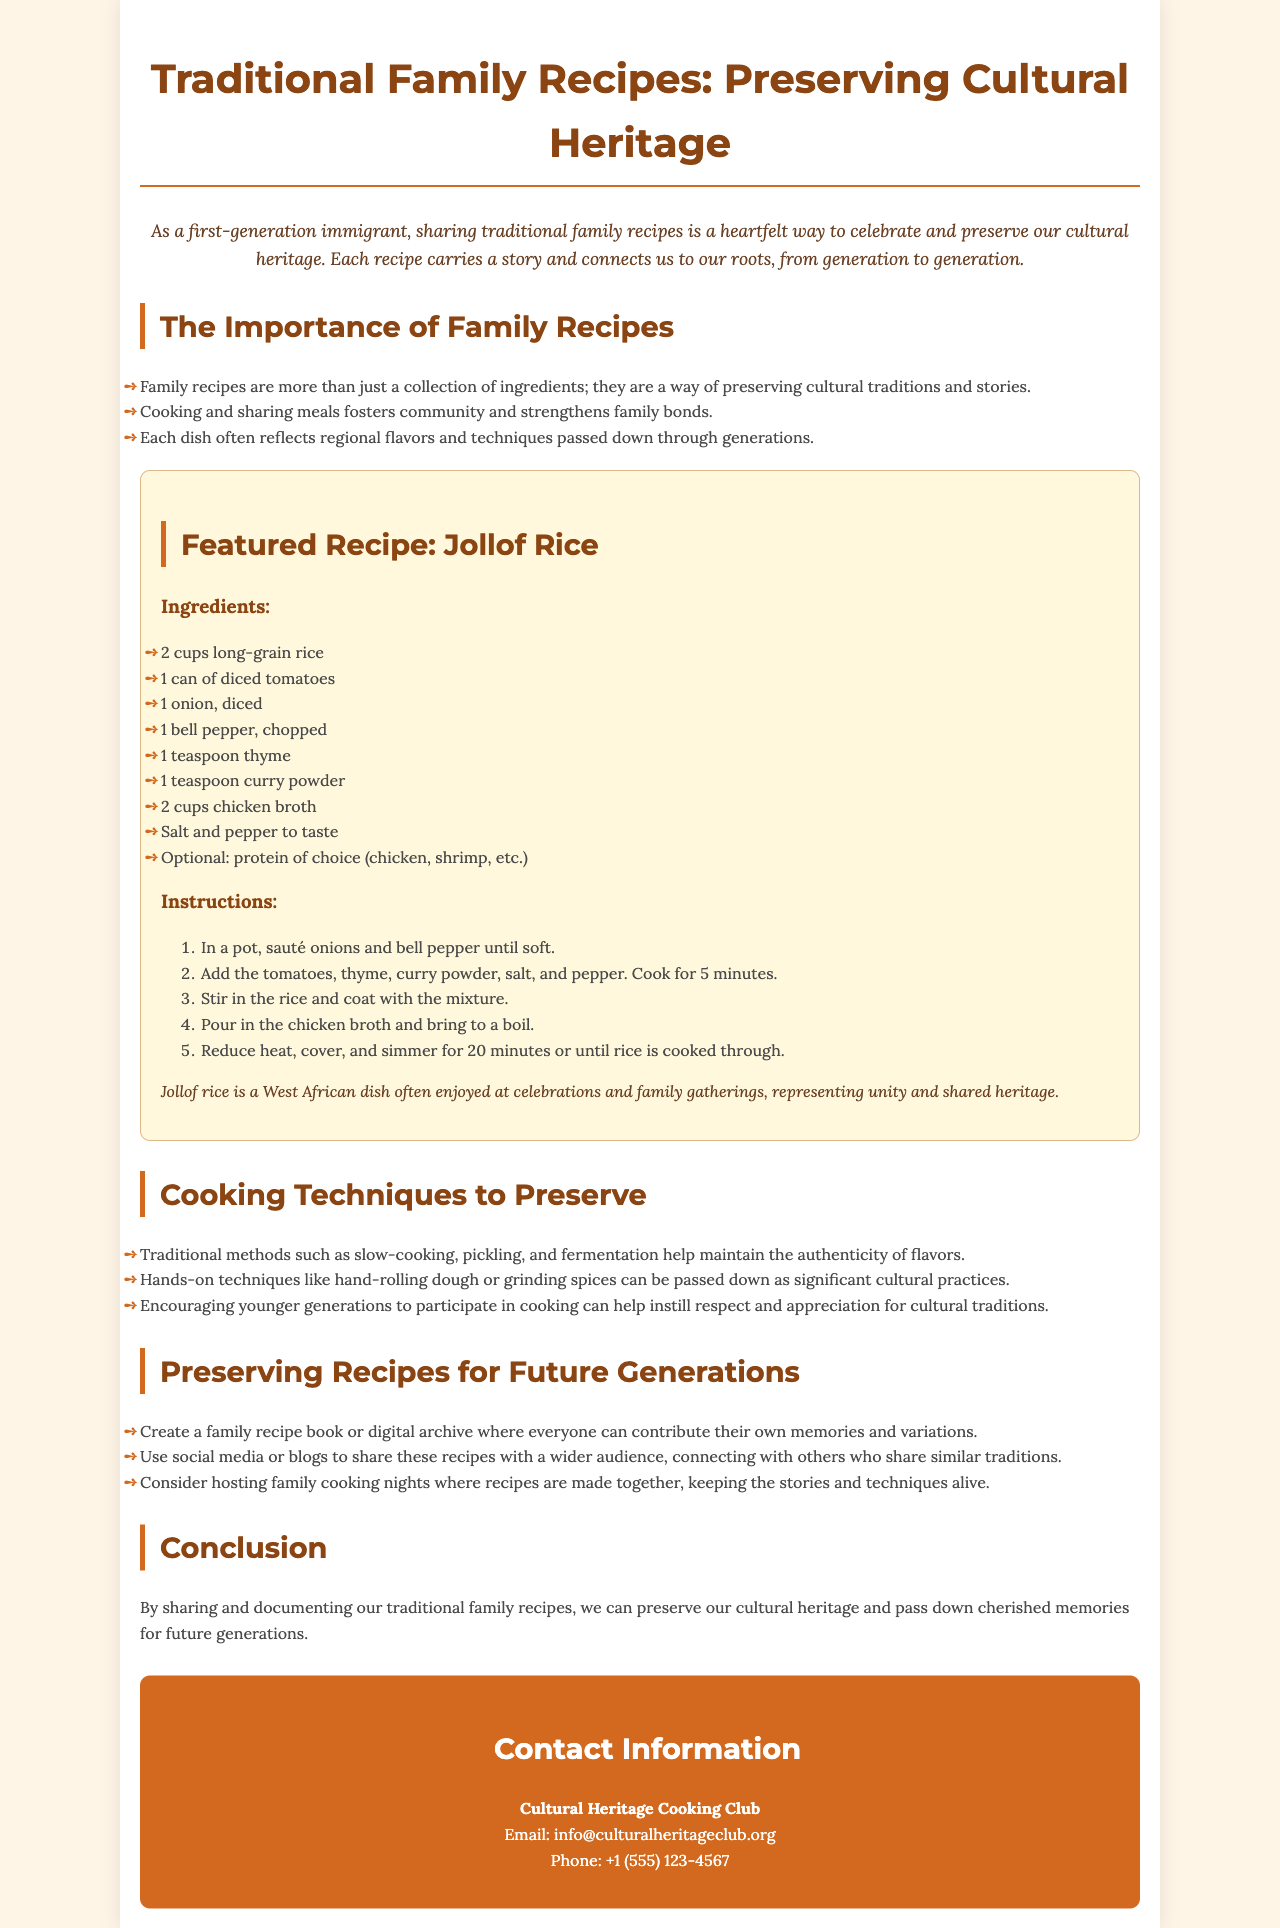What is the title of the brochure? The title of the brochure is prominently displayed at the top and is "Traditional Family Recipes: Preserving Cultural Heritage."
Answer: Traditional Family Recipes: Preserving Cultural Heritage What dish is featured in the document? The featured recipe in the document is specified in the recipe section, which is "Jollof Rice."
Answer: Jollof Rice How many cups of rice are needed for the recipe? The ingredients for Jollof Rice list "2 cups long-grain rice" as a requirement.
Answer: 2 cups What cooking technique is emphasized for preserving authenticity? The document highlights "slow-cooking" as a traditional method to maintain authenticity of flavors.
Answer: slow-cooking What is one way to engage younger generations in cooking? The document suggests "participating in cooking" as a way to engage younger generations.
Answer: participating in cooking What is the contact email provided in the brochure? The contact information section lists the email as "info@culturalheritageclub.org."
Answer: info@culturalheritageclub.org What cultural context does Jollof Rice represent? The text mentions that Jollof Rice "represents unity and shared heritage."
Answer: unity and shared heritage What is the purpose of documenting family recipes? The conclusion states that the purpose is to "preserve our cultural heritage."
Answer: preserve our cultural heritage What role do family cooking nights play? According to the document, family cooking nights help "keep the stories and techniques alive."
Answer: keep the stories and techniques alive 